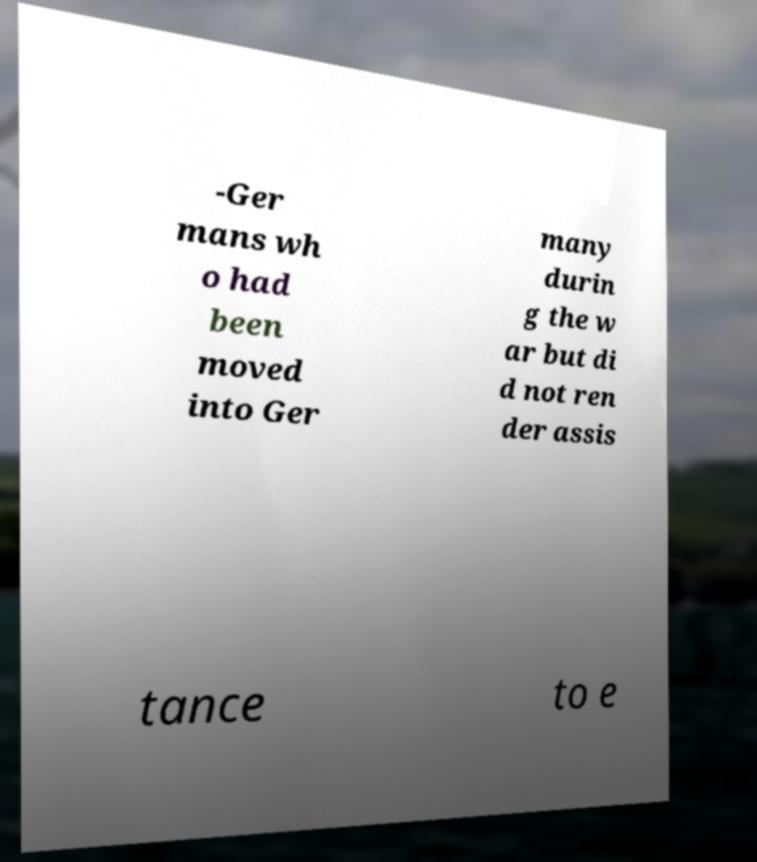There's text embedded in this image that I need extracted. Can you transcribe it verbatim? -Ger mans wh o had been moved into Ger many durin g the w ar but di d not ren der assis tance to e 